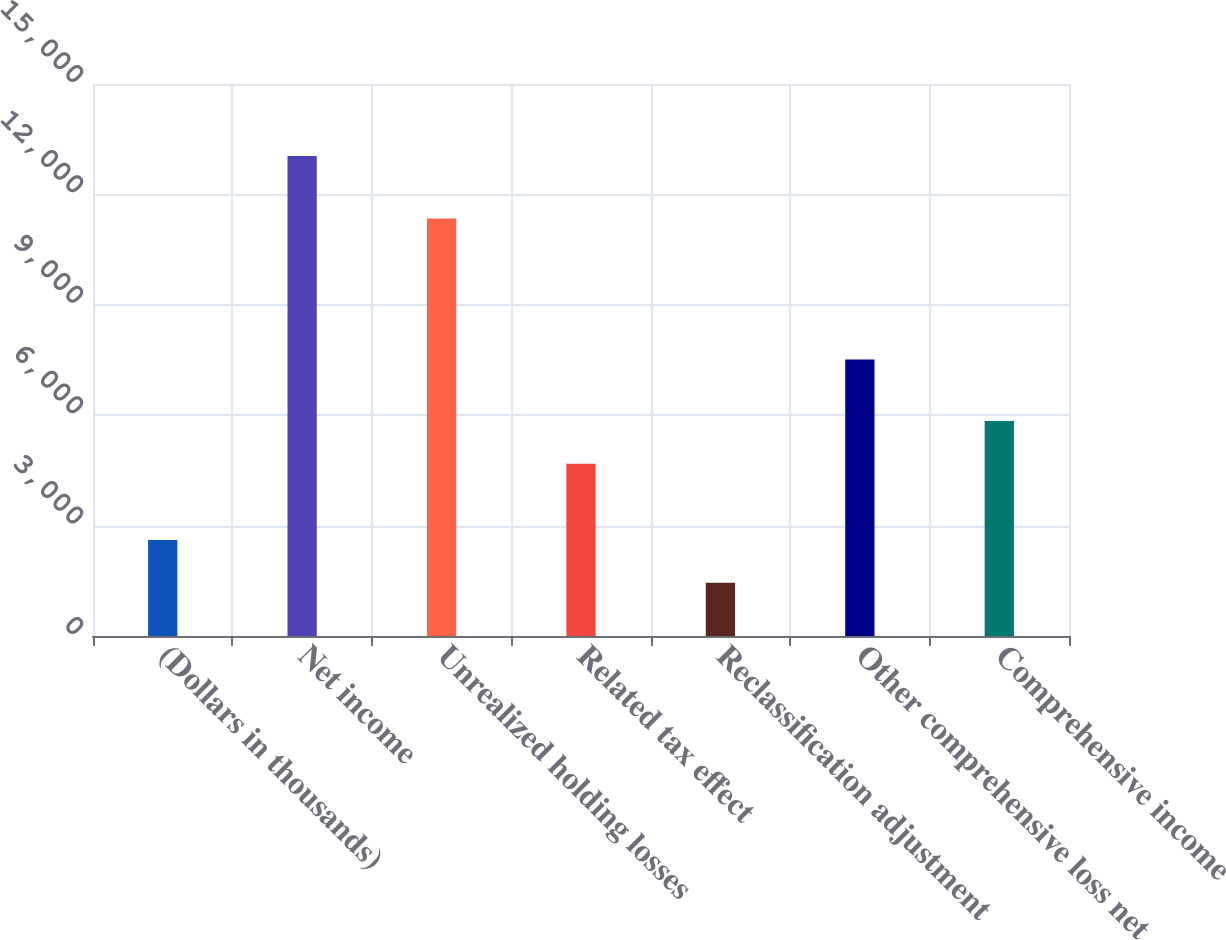<chart> <loc_0><loc_0><loc_500><loc_500><bar_chart><fcel>(Dollars in thousands)<fcel>Net income<fcel>Unrealized holding losses<fcel>Related tax effect<fcel>Reclassification adjustment<fcel>Other comprehensive loss net<fcel>Comprehensive income<nl><fcel>2606.5<fcel>13042<fcel>11347<fcel>4683<fcel>1447<fcel>7514<fcel>5842.5<nl></chart> 